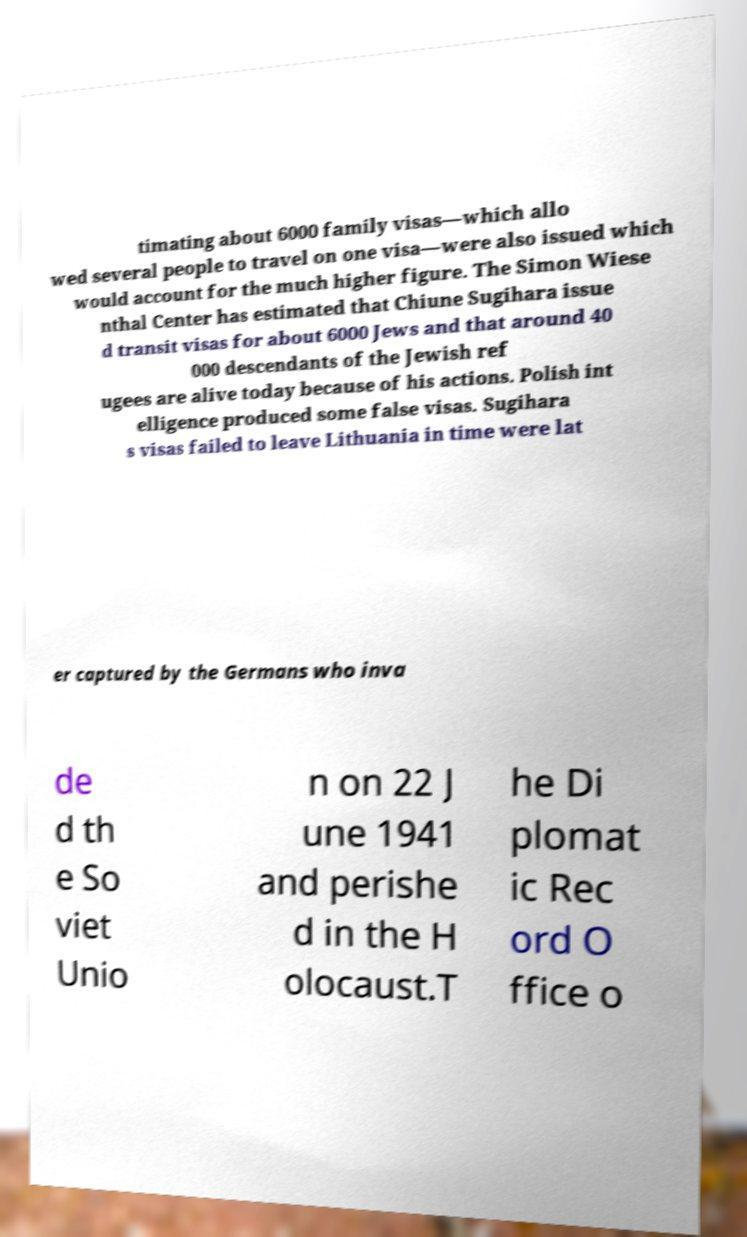Please read and relay the text visible in this image. What does it say? timating about 6000 family visas—which allo wed several people to travel on one visa—were also issued which would account for the much higher figure. The Simon Wiese nthal Center has estimated that Chiune Sugihara issue d transit visas for about 6000 Jews and that around 40 000 descendants of the Jewish ref ugees are alive today because of his actions. Polish int elligence produced some false visas. Sugihara s visas failed to leave Lithuania in time were lat er captured by the Germans who inva de d th e So viet Unio n on 22 J une 1941 and perishe d in the H olocaust.T he Di plomat ic Rec ord O ffice o 